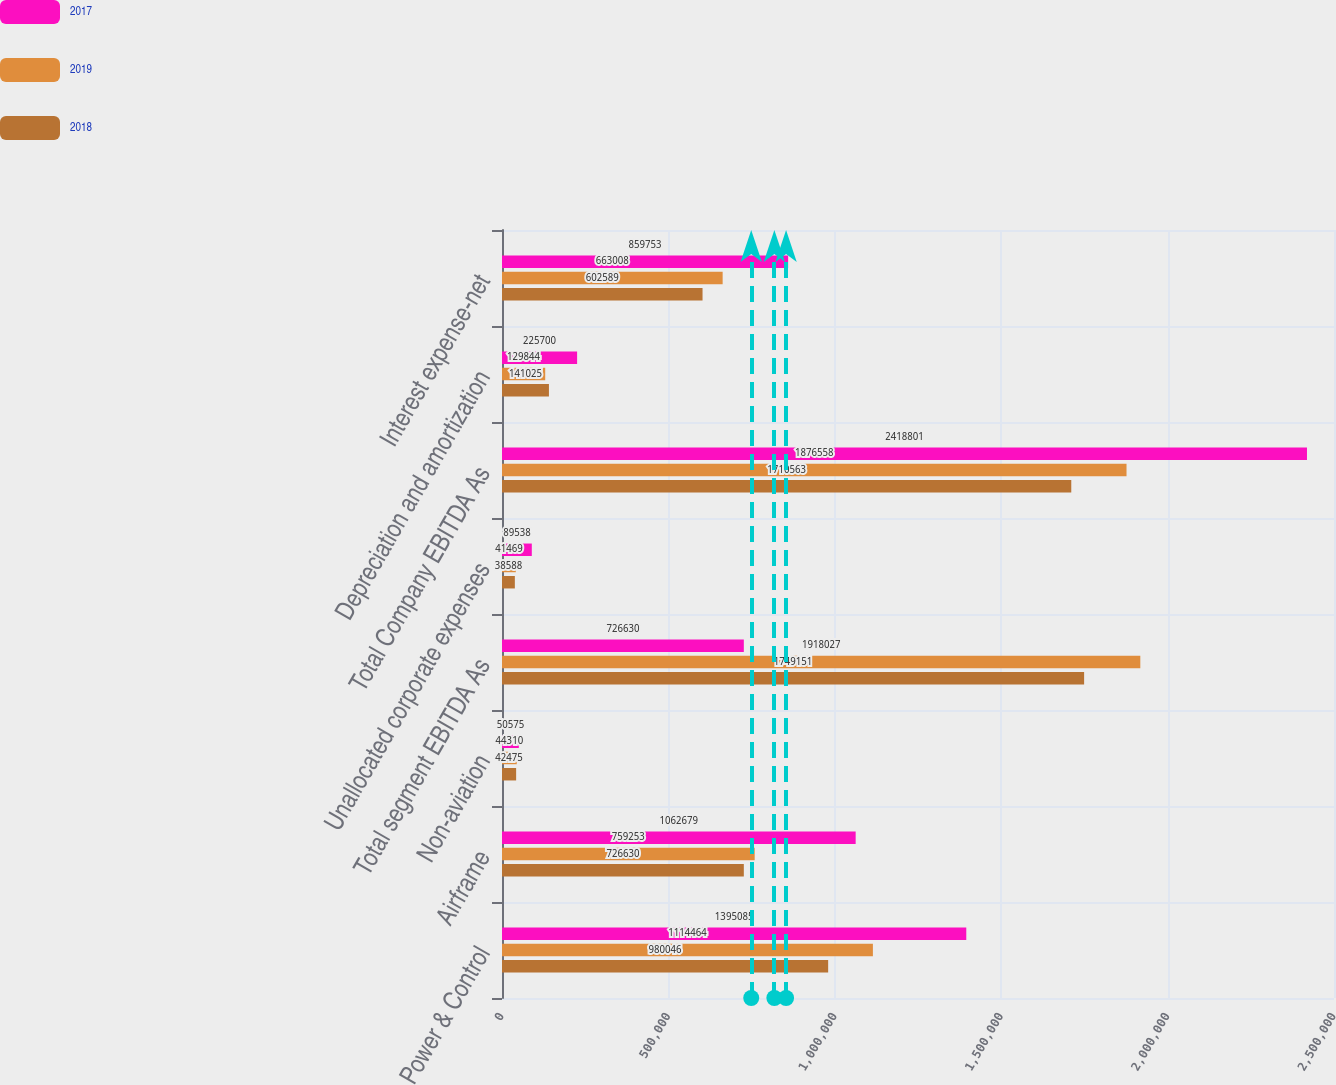Convert chart. <chart><loc_0><loc_0><loc_500><loc_500><stacked_bar_chart><ecel><fcel>Power & Control<fcel>Airframe<fcel>Non-aviation<fcel>Total segment EBITDA As<fcel>Unallocated corporate expenses<fcel>Total Company EBITDA As<fcel>Depreciation and amortization<fcel>Interest expense-net<nl><fcel>2017<fcel>1.39508e+06<fcel>1.06268e+06<fcel>50575<fcel>726630<fcel>89538<fcel>2.4188e+06<fcel>225700<fcel>859753<nl><fcel>2019<fcel>1.11446e+06<fcel>759253<fcel>44310<fcel>1.91803e+06<fcel>41469<fcel>1.87656e+06<fcel>129844<fcel>663008<nl><fcel>2018<fcel>980046<fcel>726630<fcel>42475<fcel>1.74915e+06<fcel>38588<fcel>1.71056e+06<fcel>141025<fcel>602589<nl></chart> 